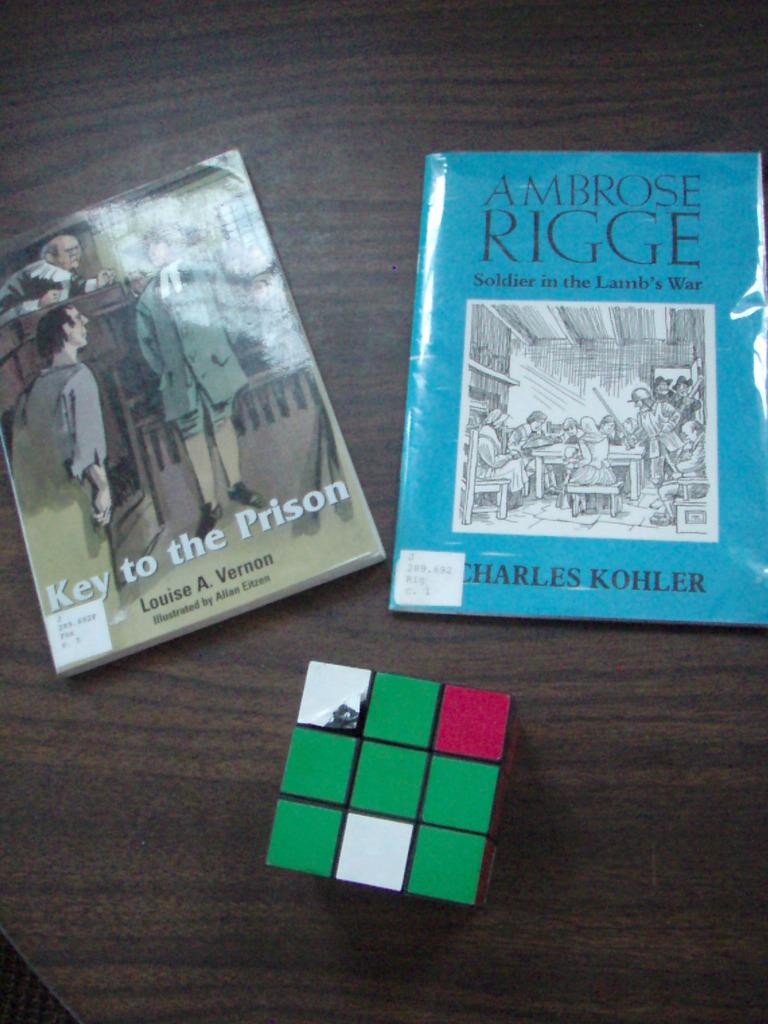<image>
Summarize the visual content of the image. A copy of Key to the Prison sits on a table near another book and a Rubik's cube. 